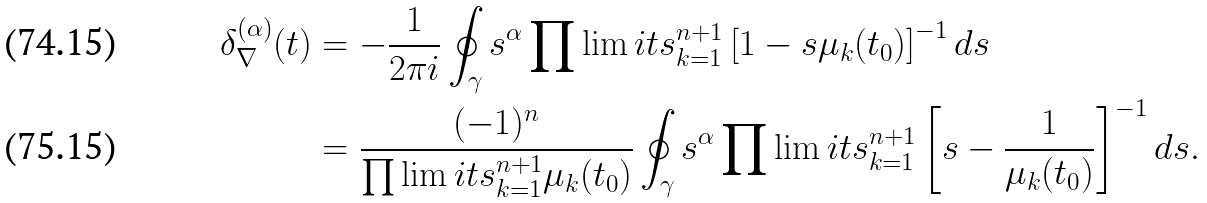Convert formula to latex. <formula><loc_0><loc_0><loc_500><loc_500>\delta _ { \nabla } ^ { ( \alpha ) } ( t ) & = - \frac { 1 } { 2 \pi i } \oint _ { \gamma } s ^ { \alpha } \prod \lim i t s _ { k = 1 } ^ { n + 1 } \left [ 1 - s \mu _ { k } ( t _ { 0 } ) \right ] ^ { - 1 } d s \\ & = \frac { ( - 1 ) ^ { n } } { \prod \lim i t s _ { k = 1 } ^ { n + 1 } \mu _ { k } ( t _ { 0 } ) } \oint _ { \gamma } s ^ { \alpha } \prod \lim i t s _ { k = 1 } ^ { n + 1 } \left [ s - \frac { 1 } { \mu _ { k } ( t _ { 0 } ) } \right ] ^ { - 1 } d s .</formula> 